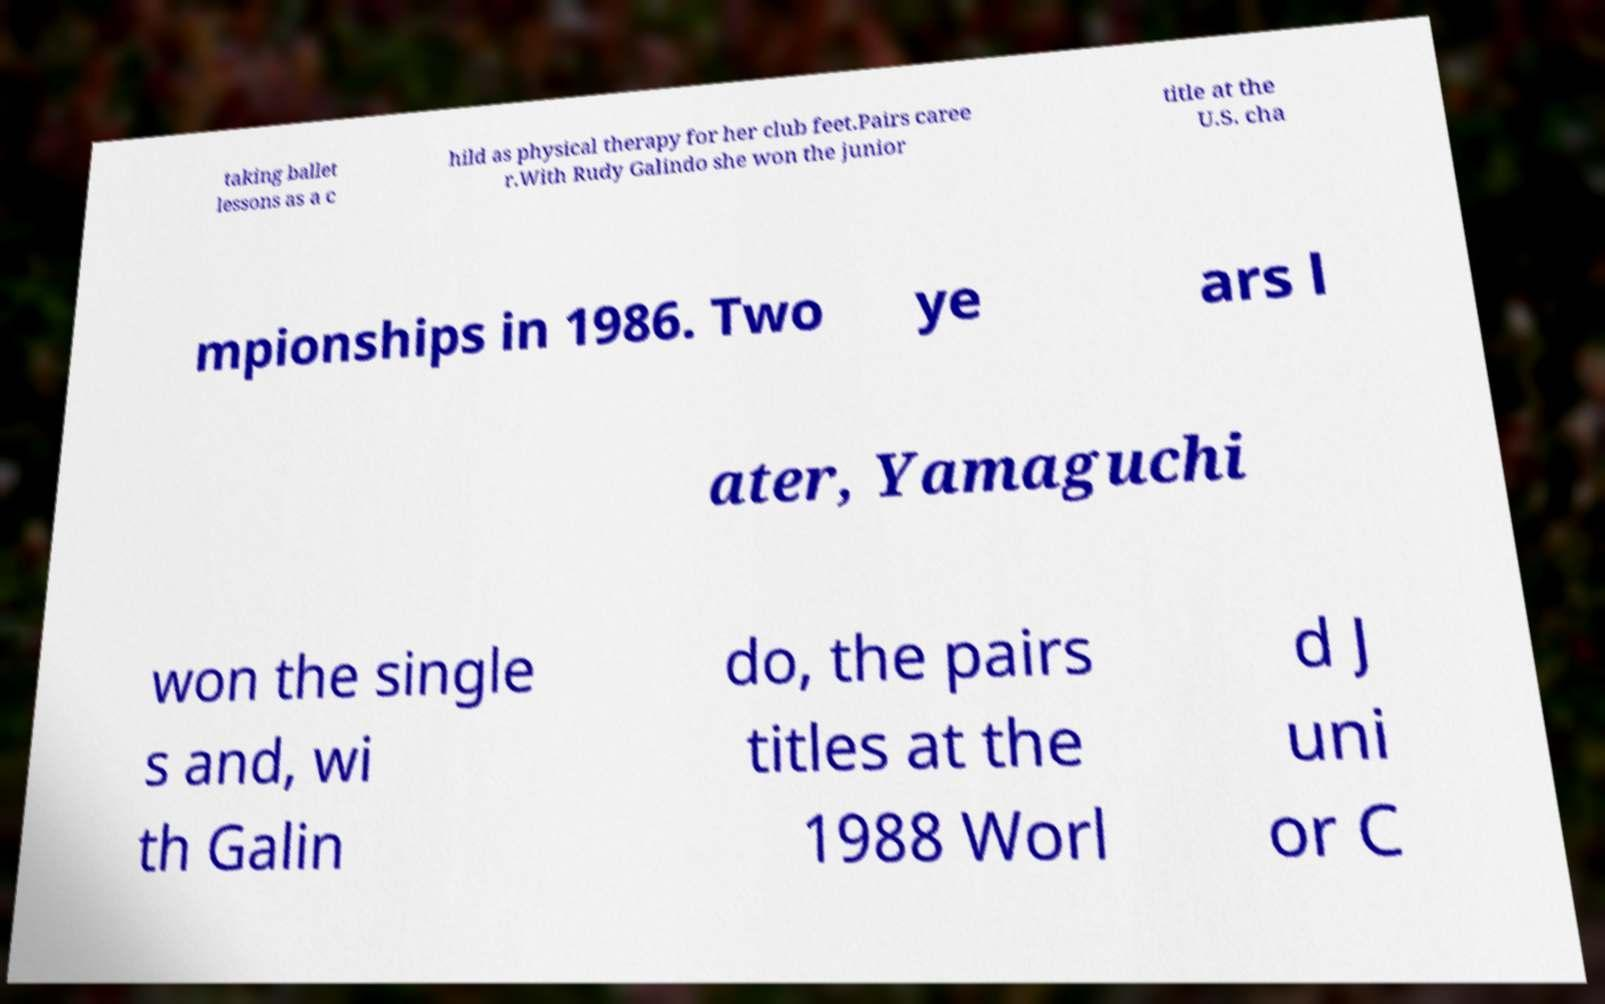Could you assist in decoding the text presented in this image and type it out clearly? taking ballet lessons as a c hild as physical therapy for her club feet.Pairs caree r.With Rudy Galindo she won the junior title at the U.S. cha mpionships in 1986. Two ye ars l ater, Yamaguchi won the single s and, wi th Galin do, the pairs titles at the 1988 Worl d J uni or C 